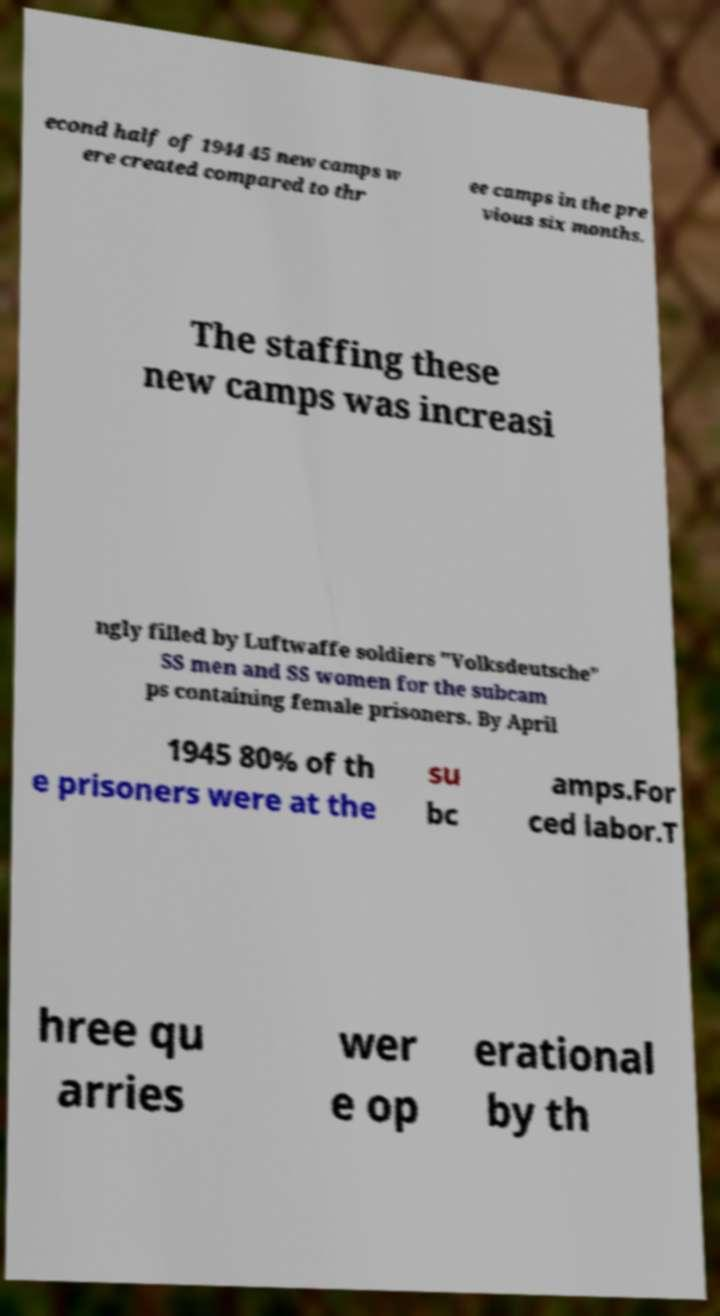For documentation purposes, I need the text within this image transcribed. Could you provide that? econd half of 1944 45 new camps w ere created compared to thr ee camps in the pre vious six months. The staffing these new camps was increasi ngly filled by Luftwaffe soldiers "Volksdeutsche" SS men and SS women for the subcam ps containing female prisoners. By April 1945 80% of th e prisoners were at the su bc amps.For ced labor.T hree qu arries wer e op erational by th 